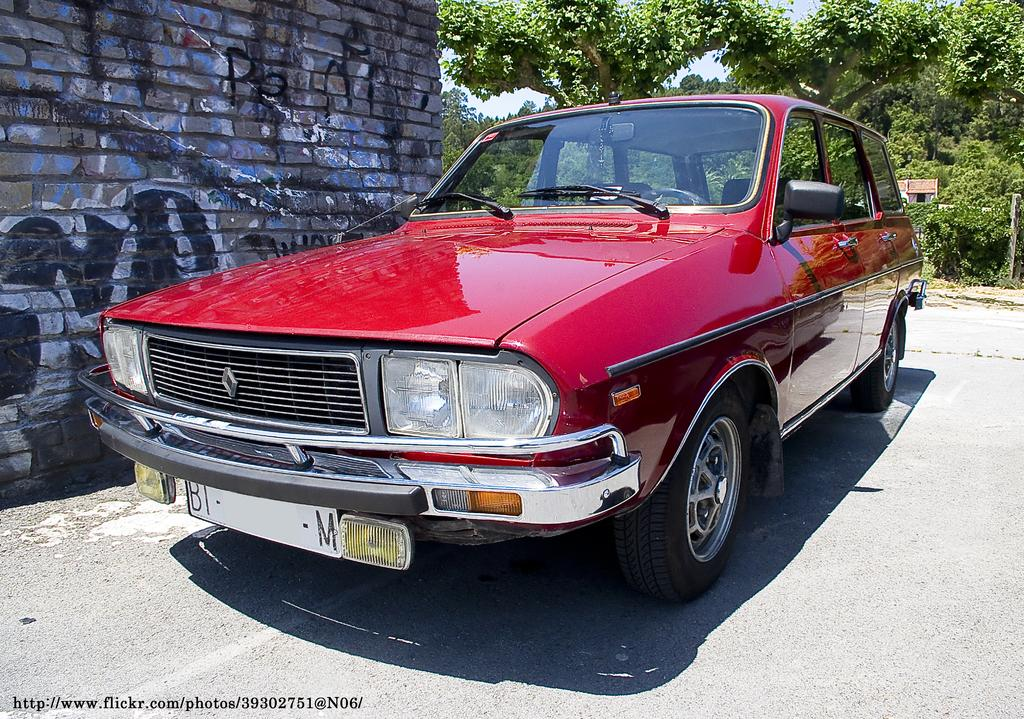What color is the car in the image? The car in the image is red. What is the car doing in the image? The car is parked. Where is the car located in relation to the building? The car is in front of a building. What can be seen in the background of the image? There are trees, a building, and the sky visible in the background of the image. What type of slope can be seen in the image? There is no slope present in the image; it features a parked red car in front of a building. What kind of doll is sitting on the roof of the car? There is no doll present on the car or in the image. 